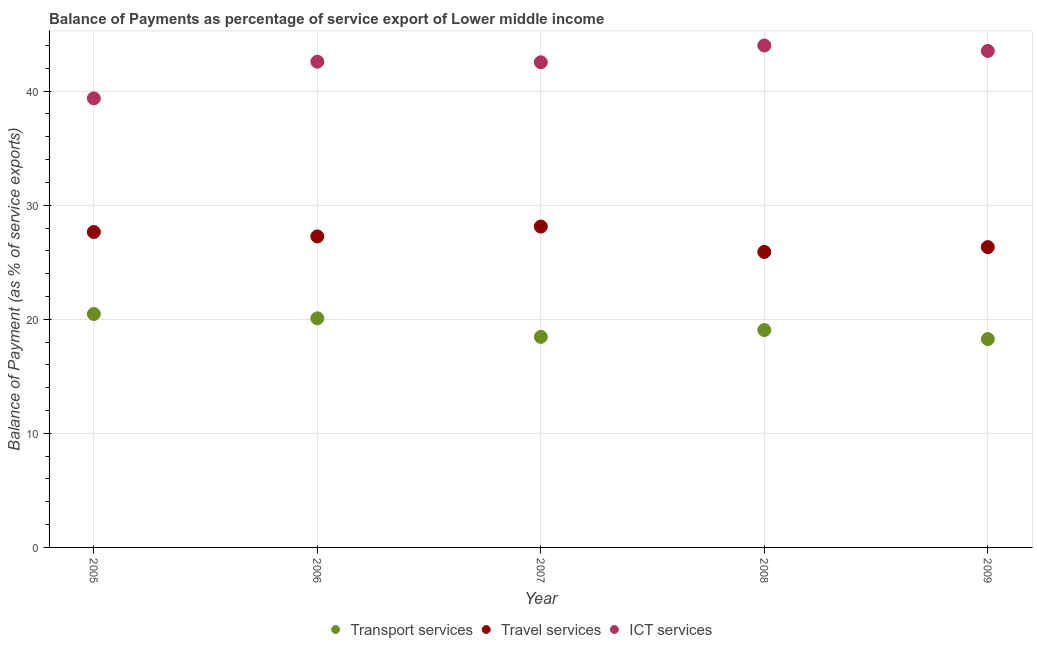How many different coloured dotlines are there?
Provide a short and direct response. 3. Is the number of dotlines equal to the number of legend labels?
Your answer should be very brief. Yes. What is the balance of payment of ict services in 2009?
Offer a terse response. 43.53. Across all years, what is the maximum balance of payment of transport services?
Keep it short and to the point. 20.47. Across all years, what is the minimum balance of payment of travel services?
Offer a terse response. 25.91. What is the total balance of payment of transport services in the graph?
Make the answer very short. 96.34. What is the difference between the balance of payment of ict services in 2008 and that in 2009?
Offer a very short reply. 0.48. What is the difference between the balance of payment of transport services in 2006 and the balance of payment of travel services in 2005?
Make the answer very short. -7.57. What is the average balance of payment of ict services per year?
Provide a short and direct response. 42.4. In the year 2008, what is the difference between the balance of payment of ict services and balance of payment of travel services?
Give a very brief answer. 18.1. In how many years, is the balance of payment of transport services greater than 14 %?
Give a very brief answer. 5. What is the ratio of the balance of payment of travel services in 2005 to that in 2007?
Your answer should be very brief. 0.98. Is the balance of payment of travel services in 2007 less than that in 2009?
Your answer should be compact. No. What is the difference between the highest and the second highest balance of payment of transport services?
Give a very brief answer. 0.38. What is the difference between the highest and the lowest balance of payment of transport services?
Provide a succinct answer. 2.2. Does the balance of payment of transport services monotonically increase over the years?
Make the answer very short. No. Is the balance of payment of transport services strictly greater than the balance of payment of travel services over the years?
Provide a short and direct response. No. Does the graph contain any zero values?
Your response must be concise. No. Does the graph contain grids?
Give a very brief answer. Yes. Where does the legend appear in the graph?
Keep it short and to the point. Bottom center. What is the title of the graph?
Provide a short and direct response. Balance of Payments as percentage of service export of Lower middle income. What is the label or title of the X-axis?
Ensure brevity in your answer.  Year. What is the label or title of the Y-axis?
Give a very brief answer. Balance of Payment (as % of service exports). What is the Balance of Payment (as % of service exports) of Transport services in 2005?
Keep it short and to the point. 20.47. What is the Balance of Payment (as % of service exports) of Travel services in 2005?
Make the answer very short. 27.65. What is the Balance of Payment (as % of service exports) of ICT services in 2005?
Keep it short and to the point. 39.37. What is the Balance of Payment (as % of service exports) of Transport services in 2006?
Offer a terse response. 20.08. What is the Balance of Payment (as % of service exports) of Travel services in 2006?
Your response must be concise. 27.27. What is the Balance of Payment (as % of service exports) in ICT services in 2006?
Provide a succinct answer. 42.58. What is the Balance of Payment (as % of service exports) in Transport services in 2007?
Provide a short and direct response. 18.46. What is the Balance of Payment (as % of service exports) of Travel services in 2007?
Keep it short and to the point. 28.13. What is the Balance of Payment (as % of service exports) of ICT services in 2007?
Your answer should be compact. 42.53. What is the Balance of Payment (as % of service exports) of Transport services in 2008?
Your answer should be compact. 19.06. What is the Balance of Payment (as % of service exports) in Travel services in 2008?
Your answer should be very brief. 25.91. What is the Balance of Payment (as % of service exports) of ICT services in 2008?
Provide a short and direct response. 44. What is the Balance of Payment (as % of service exports) in Transport services in 2009?
Keep it short and to the point. 18.27. What is the Balance of Payment (as % of service exports) in Travel services in 2009?
Give a very brief answer. 26.33. What is the Balance of Payment (as % of service exports) of ICT services in 2009?
Provide a short and direct response. 43.53. Across all years, what is the maximum Balance of Payment (as % of service exports) in Transport services?
Offer a very short reply. 20.47. Across all years, what is the maximum Balance of Payment (as % of service exports) in Travel services?
Ensure brevity in your answer.  28.13. Across all years, what is the maximum Balance of Payment (as % of service exports) in ICT services?
Your answer should be compact. 44. Across all years, what is the minimum Balance of Payment (as % of service exports) of Transport services?
Provide a succinct answer. 18.27. Across all years, what is the minimum Balance of Payment (as % of service exports) of Travel services?
Make the answer very short. 25.91. Across all years, what is the minimum Balance of Payment (as % of service exports) of ICT services?
Provide a succinct answer. 39.37. What is the total Balance of Payment (as % of service exports) in Transport services in the graph?
Provide a short and direct response. 96.34. What is the total Balance of Payment (as % of service exports) of Travel services in the graph?
Keep it short and to the point. 135.28. What is the total Balance of Payment (as % of service exports) in ICT services in the graph?
Ensure brevity in your answer.  212.02. What is the difference between the Balance of Payment (as % of service exports) of Transport services in 2005 and that in 2006?
Your answer should be compact. 0.38. What is the difference between the Balance of Payment (as % of service exports) of Travel services in 2005 and that in 2006?
Your response must be concise. 0.38. What is the difference between the Balance of Payment (as % of service exports) of ICT services in 2005 and that in 2006?
Provide a succinct answer. -3.21. What is the difference between the Balance of Payment (as % of service exports) of Transport services in 2005 and that in 2007?
Your response must be concise. 2. What is the difference between the Balance of Payment (as % of service exports) of Travel services in 2005 and that in 2007?
Your answer should be very brief. -0.48. What is the difference between the Balance of Payment (as % of service exports) in ICT services in 2005 and that in 2007?
Your response must be concise. -3.16. What is the difference between the Balance of Payment (as % of service exports) in Transport services in 2005 and that in 2008?
Give a very brief answer. 1.41. What is the difference between the Balance of Payment (as % of service exports) of Travel services in 2005 and that in 2008?
Ensure brevity in your answer.  1.74. What is the difference between the Balance of Payment (as % of service exports) of ICT services in 2005 and that in 2008?
Offer a very short reply. -4.63. What is the difference between the Balance of Payment (as % of service exports) of Transport services in 2005 and that in 2009?
Keep it short and to the point. 2.2. What is the difference between the Balance of Payment (as % of service exports) in Travel services in 2005 and that in 2009?
Make the answer very short. 1.32. What is the difference between the Balance of Payment (as % of service exports) of ICT services in 2005 and that in 2009?
Give a very brief answer. -4.16. What is the difference between the Balance of Payment (as % of service exports) of Transport services in 2006 and that in 2007?
Your answer should be compact. 1.62. What is the difference between the Balance of Payment (as % of service exports) in Travel services in 2006 and that in 2007?
Make the answer very short. -0.86. What is the difference between the Balance of Payment (as % of service exports) in ICT services in 2006 and that in 2007?
Your answer should be compact. 0.05. What is the difference between the Balance of Payment (as % of service exports) in Transport services in 2006 and that in 2008?
Offer a terse response. 1.02. What is the difference between the Balance of Payment (as % of service exports) of Travel services in 2006 and that in 2008?
Give a very brief answer. 1.36. What is the difference between the Balance of Payment (as % of service exports) in ICT services in 2006 and that in 2008?
Offer a very short reply. -1.42. What is the difference between the Balance of Payment (as % of service exports) in Transport services in 2006 and that in 2009?
Keep it short and to the point. 1.82. What is the difference between the Balance of Payment (as % of service exports) in Travel services in 2006 and that in 2009?
Make the answer very short. 0.94. What is the difference between the Balance of Payment (as % of service exports) in ICT services in 2006 and that in 2009?
Your response must be concise. -0.94. What is the difference between the Balance of Payment (as % of service exports) in Transport services in 2007 and that in 2008?
Make the answer very short. -0.6. What is the difference between the Balance of Payment (as % of service exports) of Travel services in 2007 and that in 2008?
Give a very brief answer. 2.22. What is the difference between the Balance of Payment (as % of service exports) in ICT services in 2007 and that in 2008?
Offer a very short reply. -1.47. What is the difference between the Balance of Payment (as % of service exports) of Transport services in 2007 and that in 2009?
Make the answer very short. 0.19. What is the difference between the Balance of Payment (as % of service exports) in Travel services in 2007 and that in 2009?
Offer a very short reply. 1.8. What is the difference between the Balance of Payment (as % of service exports) in ICT services in 2007 and that in 2009?
Keep it short and to the point. -0.99. What is the difference between the Balance of Payment (as % of service exports) of Transport services in 2008 and that in 2009?
Offer a very short reply. 0.79. What is the difference between the Balance of Payment (as % of service exports) of Travel services in 2008 and that in 2009?
Your answer should be very brief. -0.42. What is the difference between the Balance of Payment (as % of service exports) of ICT services in 2008 and that in 2009?
Ensure brevity in your answer.  0.48. What is the difference between the Balance of Payment (as % of service exports) in Transport services in 2005 and the Balance of Payment (as % of service exports) in Travel services in 2006?
Offer a terse response. -6.8. What is the difference between the Balance of Payment (as % of service exports) of Transport services in 2005 and the Balance of Payment (as % of service exports) of ICT services in 2006?
Make the answer very short. -22.12. What is the difference between the Balance of Payment (as % of service exports) in Travel services in 2005 and the Balance of Payment (as % of service exports) in ICT services in 2006?
Your response must be concise. -14.93. What is the difference between the Balance of Payment (as % of service exports) in Transport services in 2005 and the Balance of Payment (as % of service exports) in Travel services in 2007?
Provide a short and direct response. -7.66. What is the difference between the Balance of Payment (as % of service exports) of Transport services in 2005 and the Balance of Payment (as % of service exports) of ICT services in 2007?
Your response must be concise. -22.07. What is the difference between the Balance of Payment (as % of service exports) in Travel services in 2005 and the Balance of Payment (as % of service exports) in ICT services in 2007?
Offer a terse response. -14.88. What is the difference between the Balance of Payment (as % of service exports) of Transport services in 2005 and the Balance of Payment (as % of service exports) of Travel services in 2008?
Keep it short and to the point. -5.44. What is the difference between the Balance of Payment (as % of service exports) in Transport services in 2005 and the Balance of Payment (as % of service exports) in ICT services in 2008?
Your answer should be compact. -23.54. What is the difference between the Balance of Payment (as % of service exports) of Travel services in 2005 and the Balance of Payment (as % of service exports) of ICT services in 2008?
Keep it short and to the point. -16.35. What is the difference between the Balance of Payment (as % of service exports) of Transport services in 2005 and the Balance of Payment (as % of service exports) of Travel services in 2009?
Your answer should be compact. -5.86. What is the difference between the Balance of Payment (as % of service exports) of Transport services in 2005 and the Balance of Payment (as % of service exports) of ICT services in 2009?
Give a very brief answer. -23.06. What is the difference between the Balance of Payment (as % of service exports) in Travel services in 2005 and the Balance of Payment (as % of service exports) in ICT services in 2009?
Offer a terse response. -15.87. What is the difference between the Balance of Payment (as % of service exports) of Transport services in 2006 and the Balance of Payment (as % of service exports) of Travel services in 2007?
Your answer should be compact. -8.05. What is the difference between the Balance of Payment (as % of service exports) of Transport services in 2006 and the Balance of Payment (as % of service exports) of ICT services in 2007?
Ensure brevity in your answer.  -22.45. What is the difference between the Balance of Payment (as % of service exports) in Travel services in 2006 and the Balance of Payment (as % of service exports) in ICT services in 2007?
Your answer should be very brief. -15.27. What is the difference between the Balance of Payment (as % of service exports) of Transport services in 2006 and the Balance of Payment (as % of service exports) of Travel services in 2008?
Your answer should be very brief. -5.82. What is the difference between the Balance of Payment (as % of service exports) in Transport services in 2006 and the Balance of Payment (as % of service exports) in ICT services in 2008?
Your response must be concise. -23.92. What is the difference between the Balance of Payment (as % of service exports) in Travel services in 2006 and the Balance of Payment (as % of service exports) in ICT services in 2008?
Give a very brief answer. -16.74. What is the difference between the Balance of Payment (as % of service exports) in Transport services in 2006 and the Balance of Payment (as % of service exports) in Travel services in 2009?
Make the answer very short. -6.24. What is the difference between the Balance of Payment (as % of service exports) in Transport services in 2006 and the Balance of Payment (as % of service exports) in ICT services in 2009?
Offer a very short reply. -23.44. What is the difference between the Balance of Payment (as % of service exports) of Travel services in 2006 and the Balance of Payment (as % of service exports) of ICT services in 2009?
Ensure brevity in your answer.  -16.26. What is the difference between the Balance of Payment (as % of service exports) in Transport services in 2007 and the Balance of Payment (as % of service exports) in Travel services in 2008?
Provide a short and direct response. -7.45. What is the difference between the Balance of Payment (as % of service exports) in Transport services in 2007 and the Balance of Payment (as % of service exports) in ICT services in 2008?
Keep it short and to the point. -25.54. What is the difference between the Balance of Payment (as % of service exports) of Travel services in 2007 and the Balance of Payment (as % of service exports) of ICT services in 2008?
Your answer should be very brief. -15.87. What is the difference between the Balance of Payment (as % of service exports) of Transport services in 2007 and the Balance of Payment (as % of service exports) of Travel services in 2009?
Provide a short and direct response. -7.86. What is the difference between the Balance of Payment (as % of service exports) in Transport services in 2007 and the Balance of Payment (as % of service exports) in ICT services in 2009?
Your answer should be very brief. -25.06. What is the difference between the Balance of Payment (as % of service exports) in Travel services in 2007 and the Balance of Payment (as % of service exports) in ICT services in 2009?
Ensure brevity in your answer.  -15.4. What is the difference between the Balance of Payment (as % of service exports) in Transport services in 2008 and the Balance of Payment (as % of service exports) in Travel services in 2009?
Keep it short and to the point. -7.27. What is the difference between the Balance of Payment (as % of service exports) of Transport services in 2008 and the Balance of Payment (as % of service exports) of ICT services in 2009?
Provide a short and direct response. -24.47. What is the difference between the Balance of Payment (as % of service exports) of Travel services in 2008 and the Balance of Payment (as % of service exports) of ICT services in 2009?
Keep it short and to the point. -17.62. What is the average Balance of Payment (as % of service exports) in Transport services per year?
Offer a very short reply. 19.27. What is the average Balance of Payment (as % of service exports) of Travel services per year?
Your answer should be very brief. 27.06. What is the average Balance of Payment (as % of service exports) in ICT services per year?
Provide a succinct answer. 42.4. In the year 2005, what is the difference between the Balance of Payment (as % of service exports) of Transport services and Balance of Payment (as % of service exports) of Travel services?
Offer a terse response. -7.18. In the year 2005, what is the difference between the Balance of Payment (as % of service exports) in Transport services and Balance of Payment (as % of service exports) in ICT services?
Make the answer very short. -18.9. In the year 2005, what is the difference between the Balance of Payment (as % of service exports) of Travel services and Balance of Payment (as % of service exports) of ICT services?
Provide a succinct answer. -11.72. In the year 2006, what is the difference between the Balance of Payment (as % of service exports) in Transport services and Balance of Payment (as % of service exports) in Travel services?
Provide a short and direct response. -7.18. In the year 2006, what is the difference between the Balance of Payment (as % of service exports) of Transport services and Balance of Payment (as % of service exports) of ICT services?
Your response must be concise. -22.5. In the year 2006, what is the difference between the Balance of Payment (as % of service exports) in Travel services and Balance of Payment (as % of service exports) in ICT services?
Your answer should be very brief. -15.32. In the year 2007, what is the difference between the Balance of Payment (as % of service exports) of Transport services and Balance of Payment (as % of service exports) of Travel services?
Offer a terse response. -9.67. In the year 2007, what is the difference between the Balance of Payment (as % of service exports) in Transport services and Balance of Payment (as % of service exports) in ICT services?
Your response must be concise. -24.07. In the year 2007, what is the difference between the Balance of Payment (as % of service exports) in Travel services and Balance of Payment (as % of service exports) in ICT services?
Provide a short and direct response. -14.4. In the year 2008, what is the difference between the Balance of Payment (as % of service exports) in Transport services and Balance of Payment (as % of service exports) in Travel services?
Give a very brief answer. -6.85. In the year 2008, what is the difference between the Balance of Payment (as % of service exports) of Transport services and Balance of Payment (as % of service exports) of ICT services?
Your answer should be compact. -24.94. In the year 2008, what is the difference between the Balance of Payment (as % of service exports) of Travel services and Balance of Payment (as % of service exports) of ICT services?
Keep it short and to the point. -18.1. In the year 2009, what is the difference between the Balance of Payment (as % of service exports) in Transport services and Balance of Payment (as % of service exports) in Travel services?
Your answer should be very brief. -8.06. In the year 2009, what is the difference between the Balance of Payment (as % of service exports) in Transport services and Balance of Payment (as % of service exports) in ICT services?
Ensure brevity in your answer.  -25.26. In the year 2009, what is the difference between the Balance of Payment (as % of service exports) in Travel services and Balance of Payment (as % of service exports) in ICT services?
Offer a very short reply. -17.2. What is the ratio of the Balance of Payment (as % of service exports) of Travel services in 2005 to that in 2006?
Make the answer very short. 1.01. What is the ratio of the Balance of Payment (as % of service exports) in ICT services in 2005 to that in 2006?
Your answer should be compact. 0.92. What is the ratio of the Balance of Payment (as % of service exports) of Transport services in 2005 to that in 2007?
Your response must be concise. 1.11. What is the ratio of the Balance of Payment (as % of service exports) in ICT services in 2005 to that in 2007?
Your response must be concise. 0.93. What is the ratio of the Balance of Payment (as % of service exports) of Transport services in 2005 to that in 2008?
Provide a short and direct response. 1.07. What is the ratio of the Balance of Payment (as % of service exports) of Travel services in 2005 to that in 2008?
Your answer should be compact. 1.07. What is the ratio of the Balance of Payment (as % of service exports) of ICT services in 2005 to that in 2008?
Make the answer very short. 0.89. What is the ratio of the Balance of Payment (as % of service exports) of Transport services in 2005 to that in 2009?
Provide a succinct answer. 1.12. What is the ratio of the Balance of Payment (as % of service exports) in Travel services in 2005 to that in 2009?
Provide a succinct answer. 1.05. What is the ratio of the Balance of Payment (as % of service exports) in ICT services in 2005 to that in 2009?
Provide a short and direct response. 0.9. What is the ratio of the Balance of Payment (as % of service exports) of Transport services in 2006 to that in 2007?
Give a very brief answer. 1.09. What is the ratio of the Balance of Payment (as % of service exports) in Travel services in 2006 to that in 2007?
Offer a very short reply. 0.97. What is the ratio of the Balance of Payment (as % of service exports) of Transport services in 2006 to that in 2008?
Make the answer very short. 1.05. What is the ratio of the Balance of Payment (as % of service exports) of Travel services in 2006 to that in 2008?
Offer a terse response. 1.05. What is the ratio of the Balance of Payment (as % of service exports) of ICT services in 2006 to that in 2008?
Provide a short and direct response. 0.97. What is the ratio of the Balance of Payment (as % of service exports) of Transport services in 2006 to that in 2009?
Your response must be concise. 1.1. What is the ratio of the Balance of Payment (as % of service exports) in Travel services in 2006 to that in 2009?
Make the answer very short. 1.04. What is the ratio of the Balance of Payment (as % of service exports) in ICT services in 2006 to that in 2009?
Ensure brevity in your answer.  0.98. What is the ratio of the Balance of Payment (as % of service exports) in Transport services in 2007 to that in 2008?
Provide a short and direct response. 0.97. What is the ratio of the Balance of Payment (as % of service exports) in Travel services in 2007 to that in 2008?
Make the answer very short. 1.09. What is the ratio of the Balance of Payment (as % of service exports) of ICT services in 2007 to that in 2008?
Your answer should be very brief. 0.97. What is the ratio of the Balance of Payment (as % of service exports) in Transport services in 2007 to that in 2009?
Provide a succinct answer. 1.01. What is the ratio of the Balance of Payment (as % of service exports) in Travel services in 2007 to that in 2009?
Make the answer very short. 1.07. What is the ratio of the Balance of Payment (as % of service exports) in ICT services in 2007 to that in 2009?
Provide a short and direct response. 0.98. What is the ratio of the Balance of Payment (as % of service exports) of Transport services in 2008 to that in 2009?
Give a very brief answer. 1.04. What is the ratio of the Balance of Payment (as % of service exports) of Travel services in 2008 to that in 2009?
Provide a succinct answer. 0.98. What is the ratio of the Balance of Payment (as % of service exports) of ICT services in 2008 to that in 2009?
Provide a short and direct response. 1.01. What is the difference between the highest and the second highest Balance of Payment (as % of service exports) of Transport services?
Keep it short and to the point. 0.38. What is the difference between the highest and the second highest Balance of Payment (as % of service exports) in Travel services?
Your answer should be very brief. 0.48. What is the difference between the highest and the second highest Balance of Payment (as % of service exports) in ICT services?
Offer a very short reply. 0.48. What is the difference between the highest and the lowest Balance of Payment (as % of service exports) in Transport services?
Give a very brief answer. 2.2. What is the difference between the highest and the lowest Balance of Payment (as % of service exports) of Travel services?
Your response must be concise. 2.22. What is the difference between the highest and the lowest Balance of Payment (as % of service exports) of ICT services?
Keep it short and to the point. 4.63. 